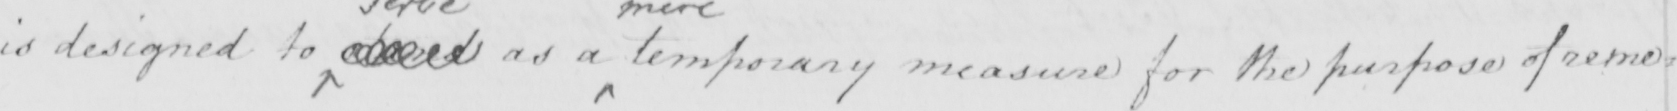Please transcribe the handwritten text in this image. is designed to stand as a temporary measure for the purpose of reme= 